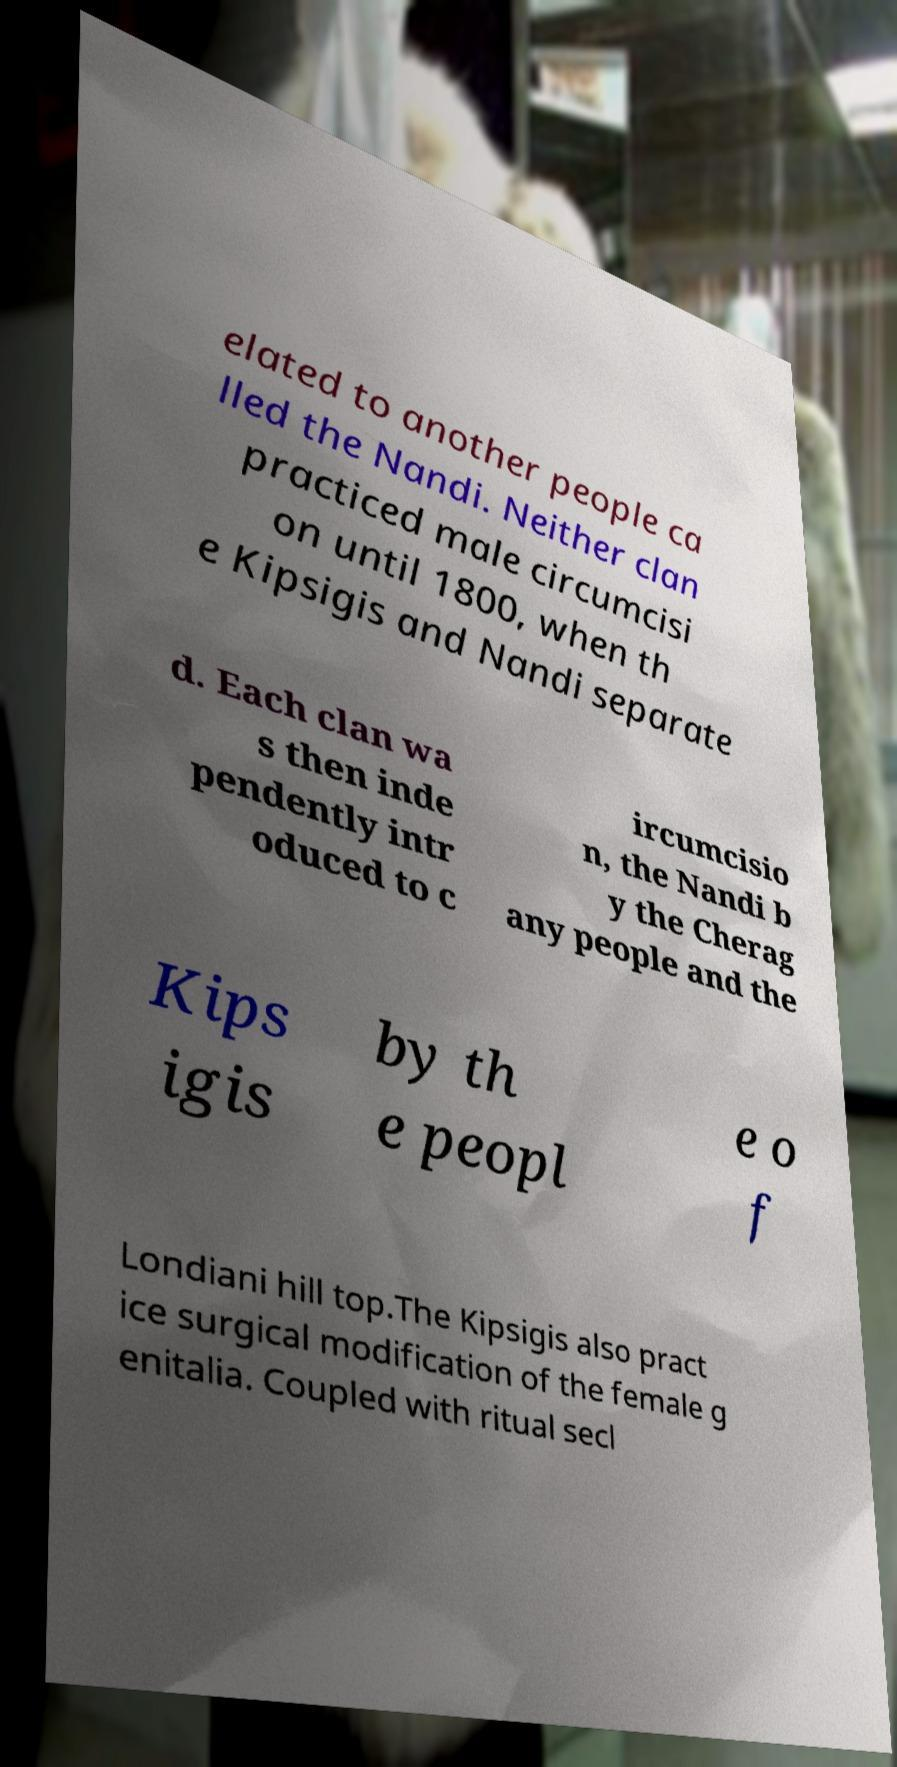What messages or text are displayed in this image? I need them in a readable, typed format. elated to another people ca lled the Nandi. Neither clan practiced male circumcisi on until 1800, when th e Kipsigis and Nandi separate d. Each clan wa s then inde pendently intr oduced to c ircumcisio n, the Nandi b y the Cherag any people and the Kips igis by th e peopl e o f Londiani hill top.The Kipsigis also pract ice surgical modification of the female g enitalia. Coupled with ritual secl 